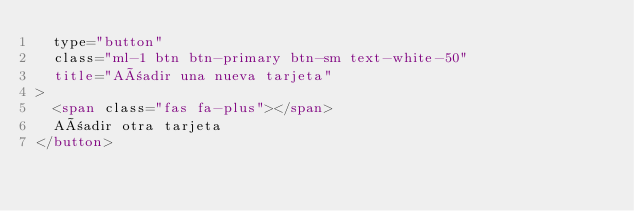Convert code to text. <code><loc_0><loc_0><loc_500><loc_500><_HTML_>  type="button"
  class="ml-1 btn btn-primary btn-sm text-white-50"
  title="Añadir una nueva tarjeta"
>
  <span class="fas fa-plus"></span>
  Añadir otra tarjeta
</button></code> 